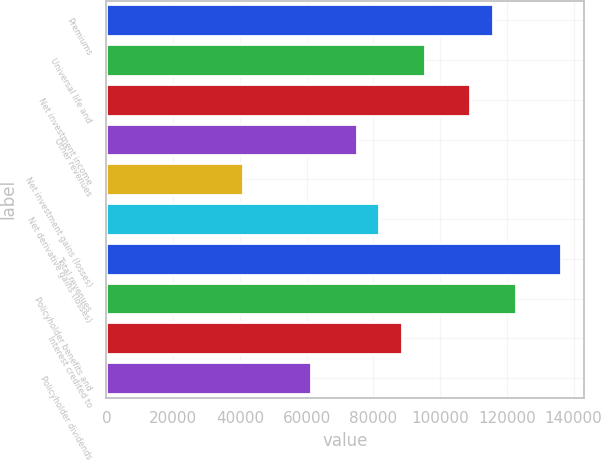Convert chart to OTSL. <chart><loc_0><loc_0><loc_500><loc_500><bar_chart><fcel>Premiums<fcel>Universal life and<fcel>Net investment income<fcel>Other revenues<fcel>Net investment gains (losses)<fcel>Net derivative gains (losses)<fcel>Total revenues<fcel>Policyholder benefits and<fcel>Interest credited to<fcel>Policyholder dividends<nl><fcel>115855<fcel>95409.8<fcel>109040<fcel>74965<fcel>40890.3<fcel>81779.9<fcel>136299<fcel>122669<fcel>88594.8<fcel>61335.1<nl></chart> 